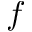Convert formula to latex. <formula><loc_0><loc_0><loc_500><loc_500>f</formula> 